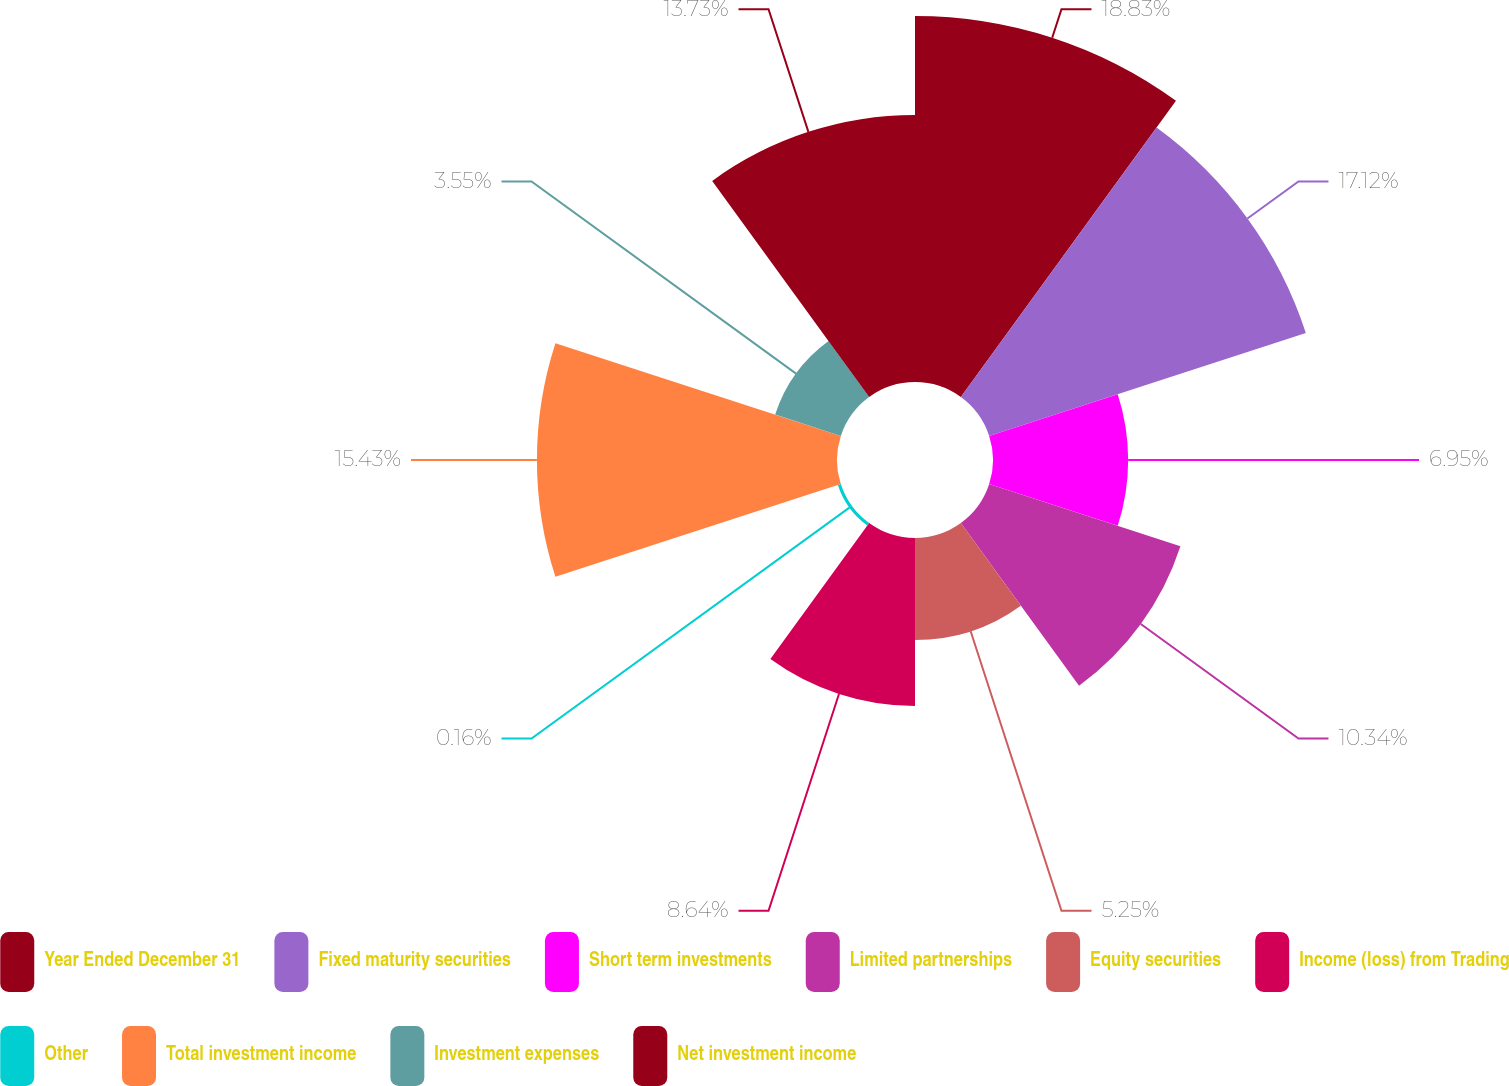Convert chart. <chart><loc_0><loc_0><loc_500><loc_500><pie_chart><fcel>Year Ended December 31<fcel>Fixed maturity securities<fcel>Short term investments<fcel>Limited partnerships<fcel>Equity securities<fcel>Income (loss) from Trading<fcel>Other<fcel>Total investment income<fcel>Investment expenses<fcel>Net investment income<nl><fcel>18.82%<fcel>17.12%<fcel>6.95%<fcel>10.34%<fcel>5.25%<fcel>8.64%<fcel>0.16%<fcel>15.43%<fcel>3.55%<fcel>13.73%<nl></chart> 